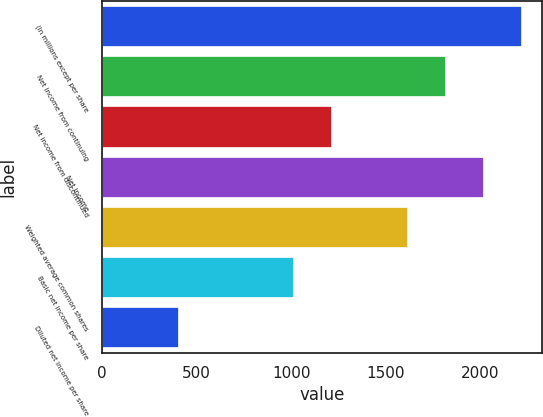Convert chart. <chart><loc_0><loc_0><loc_500><loc_500><bar_chart><fcel>(In millions except per share<fcel>Net income from continuing<fcel>Net income from discontinued<fcel>Net income<fcel>Weighted average common shares<fcel>Basic net income per share<fcel>Diluted net income per share<nl><fcel>2215.34<fcel>1812.58<fcel>1208.44<fcel>2013.96<fcel>1611.2<fcel>1007.06<fcel>402.92<nl></chart> 